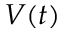<formula> <loc_0><loc_0><loc_500><loc_500>V ( t )</formula> 